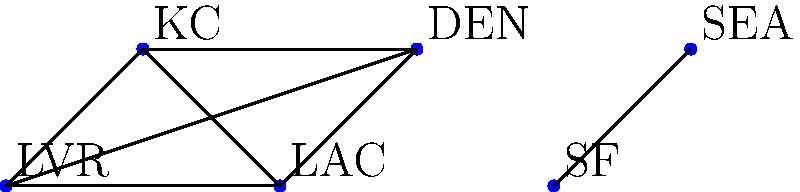In the graph above, NFL teams are represented as vertices, and edges indicate games played against each other in a season. What is the size of the maximum clique in this graph, and which teams form this clique? (Hint: Look for Derek Carr's former team) To find the maximum clique in this graph, we need to follow these steps:

1. Identify the teams in the graph:
   LVR (Las Vegas Raiders), KC (Kansas City Chiefs), LAC (Los Angeles Chargers), DEN (Denver Broncos), SF (San Francisco 49ers), and SEA (Seattle Seahawks).

2. Observe that Derek Carr's former team, the Las Vegas Raiders (LVR), is part of a group of four teams that are all connected to each other.

3. Check the connections between LVR, KC, LAC, and DEN:
   - LVR is connected to KC, LAC, and DEN
   - KC is connected to LVR, LAC, and DEN
   - LAC is connected to LVR, KC, and DEN
   - DEN is connected to LVR, KC, and LAC

4. This group of four teams (LVR, KC, LAC, DEN) forms a complete subgraph where every vertex is connected to every other vertex in the subgroup.

5. Verify that there are no larger cliques in the graph:
   - SF and SEA are only connected to each other and not to any other teams.
   - There are no connections between the group of four teams and SF or SEA.

6. Therefore, the maximum clique in this graph has a size of 4 and consists of the teams LVR, KC, LAC, and DEN.
Answer: Size: 4; Teams: LVR, KC, LAC, DEN 